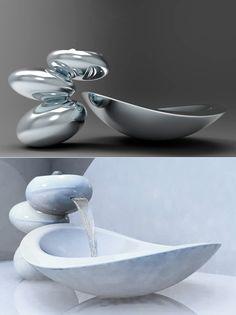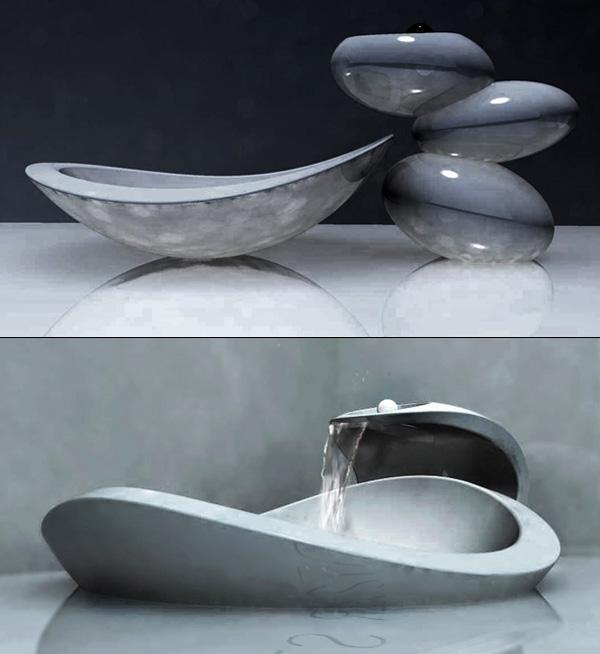The first image is the image on the left, the second image is the image on the right. Evaluate the accuracy of this statement regarding the images: "In exactly one image water is pouring from the faucet.". Is it true? Answer yes or no. No. The first image is the image on the left, the second image is the image on the right. Given the left and right images, does the statement "The left and right image contains the same number of oval sinks." hold true? Answer yes or no. Yes. 